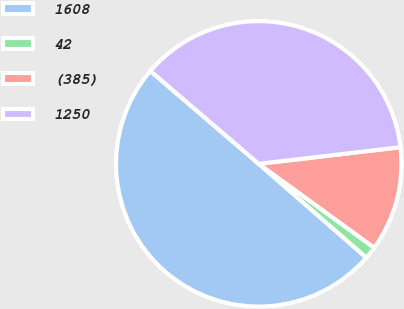Convert chart. <chart><loc_0><loc_0><loc_500><loc_500><pie_chart><fcel>1608<fcel>42<fcel>(385)<fcel>1250<nl><fcel>49.87%<fcel>1.41%<fcel>11.86%<fcel>36.86%<nl></chart> 